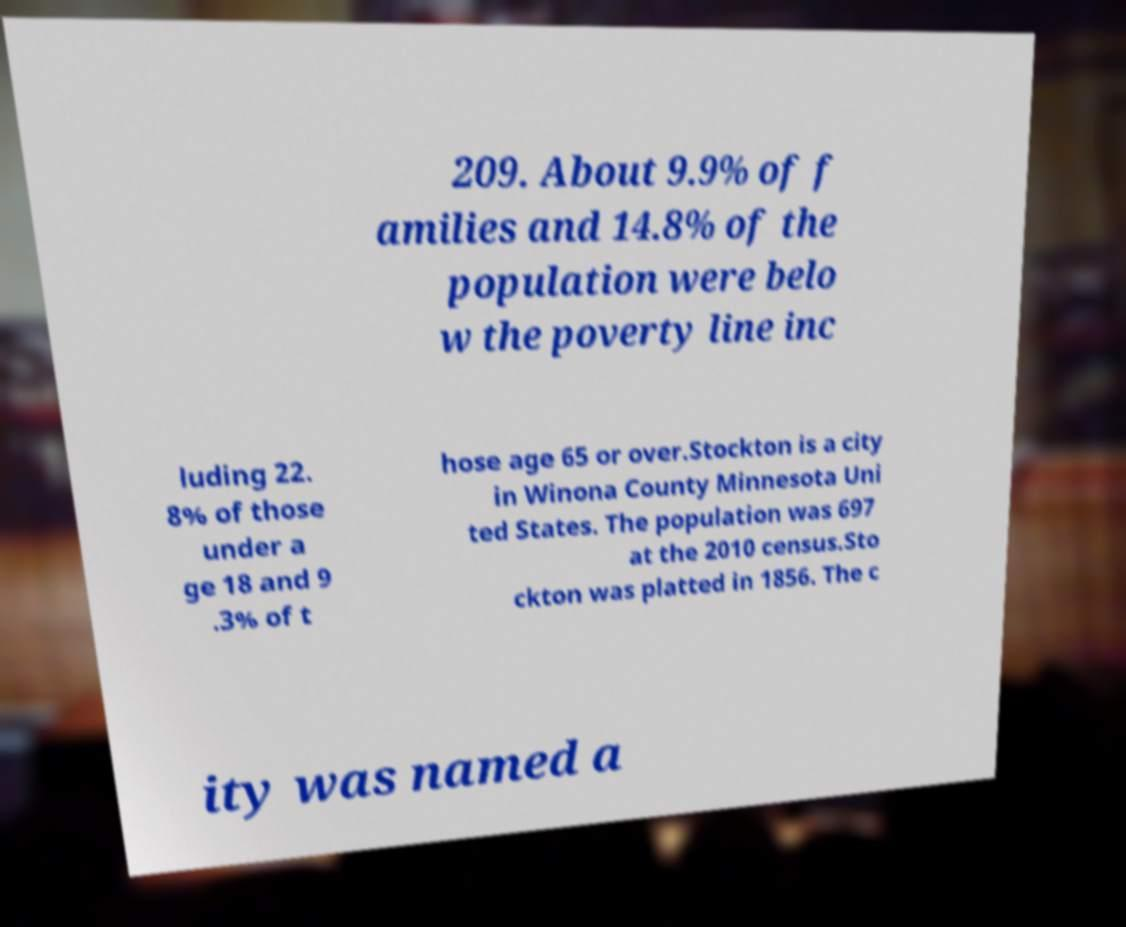I need the written content from this picture converted into text. Can you do that? 209. About 9.9% of f amilies and 14.8% of the population were belo w the poverty line inc luding 22. 8% of those under a ge 18 and 9 .3% of t hose age 65 or over.Stockton is a city in Winona County Minnesota Uni ted States. The population was 697 at the 2010 census.Sto ckton was platted in 1856. The c ity was named a 